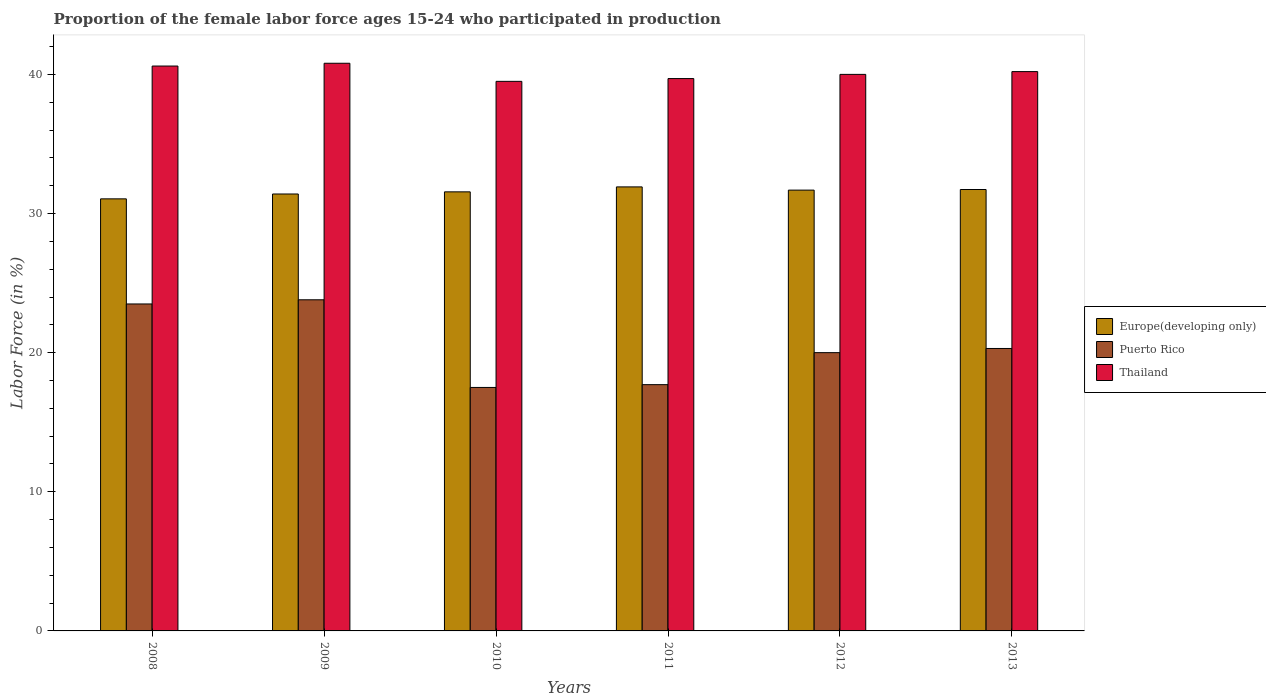Are the number of bars per tick equal to the number of legend labels?
Give a very brief answer. Yes. How many bars are there on the 4th tick from the right?
Ensure brevity in your answer.  3. What is the label of the 6th group of bars from the left?
Your response must be concise. 2013. In how many cases, is the number of bars for a given year not equal to the number of legend labels?
Give a very brief answer. 0. What is the proportion of the female labor force who participated in production in Puerto Rico in 2010?
Keep it short and to the point. 17.5. Across all years, what is the maximum proportion of the female labor force who participated in production in Puerto Rico?
Provide a short and direct response. 23.8. Across all years, what is the minimum proportion of the female labor force who participated in production in Puerto Rico?
Offer a very short reply. 17.5. In which year was the proportion of the female labor force who participated in production in Europe(developing only) maximum?
Make the answer very short. 2011. In which year was the proportion of the female labor force who participated in production in Thailand minimum?
Provide a succinct answer. 2010. What is the total proportion of the female labor force who participated in production in Europe(developing only) in the graph?
Ensure brevity in your answer.  189.34. What is the difference between the proportion of the female labor force who participated in production in Europe(developing only) in 2010 and that in 2012?
Provide a succinct answer. -0.12. What is the difference between the proportion of the female labor force who participated in production in Thailand in 2010 and the proportion of the female labor force who participated in production in Puerto Rico in 2013?
Make the answer very short. 19.2. What is the average proportion of the female labor force who participated in production in Europe(developing only) per year?
Offer a terse response. 31.56. In the year 2012, what is the difference between the proportion of the female labor force who participated in production in Europe(developing only) and proportion of the female labor force who participated in production in Thailand?
Offer a very short reply. -8.32. In how many years, is the proportion of the female labor force who participated in production in Puerto Rico greater than 14 %?
Provide a short and direct response. 6. What is the ratio of the proportion of the female labor force who participated in production in Puerto Rico in 2009 to that in 2012?
Your answer should be compact. 1.19. What is the difference between the highest and the second highest proportion of the female labor force who participated in production in Puerto Rico?
Give a very brief answer. 0.3. What is the difference between the highest and the lowest proportion of the female labor force who participated in production in Thailand?
Make the answer very short. 1.3. In how many years, is the proportion of the female labor force who participated in production in Thailand greater than the average proportion of the female labor force who participated in production in Thailand taken over all years?
Ensure brevity in your answer.  3. Is the sum of the proportion of the female labor force who participated in production in Europe(developing only) in 2011 and 2012 greater than the maximum proportion of the female labor force who participated in production in Thailand across all years?
Offer a terse response. Yes. What does the 2nd bar from the left in 2010 represents?
Ensure brevity in your answer.  Puerto Rico. What does the 3rd bar from the right in 2013 represents?
Your response must be concise. Europe(developing only). Are all the bars in the graph horizontal?
Your answer should be very brief. No. Are the values on the major ticks of Y-axis written in scientific E-notation?
Your response must be concise. No. Does the graph contain grids?
Your answer should be very brief. No. How are the legend labels stacked?
Make the answer very short. Vertical. What is the title of the graph?
Provide a short and direct response. Proportion of the female labor force ages 15-24 who participated in production. What is the Labor Force (in %) in Europe(developing only) in 2008?
Make the answer very short. 31.05. What is the Labor Force (in %) of Thailand in 2008?
Give a very brief answer. 40.6. What is the Labor Force (in %) of Europe(developing only) in 2009?
Provide a succinct answer. 31.4. What is the Labor Force (in %) of Puerto Rico in 2009?
Keep it short and to the point. 23.8. What is the Labor Force (in %) in Thailand in 2009?
Provide a short and direct response. 40.8. What is the Labor Force (in %) of Europe(developing only) in 2010?
Ensure brevity in your answer.  31.56. What is the Labor Force (in %) in Puerto Rico in 2010?
Give a very brief answer. 17.5. What is the Labor Force (in %) in Thailand in 2010?
Provide a succinct answer. 39.5. What is the Labor Force (in %) in Europe(developing only) in 2011?
Make the answer very short. 31.91. What is the Labor Force (in %) of Puerto Rico in 2011?
Offer a very short reply. 17.7. What is the Labor Force (in %) of Thailand in 2011?
Your answer should be very brief. 39.7. What is the Labor Force (in %) in Europe(developing only) in 2012?
Your answer should be compact. 31.68. What is the Labor Force (in %) in Puerto Rico in 2012?
Offer a terse response. 20. What is the Labor Force (in %) of Europe(developing only) in 2013?
Your answer should be very brief. 31.73. What is the Labor Force (in %) in Puerto Rico in 2013?
Offer a very short reply. 20.3. What is the Labor Force (in %) in Thailand in 2013?
Provide a short and direct response. 40.2. Across all years, what is the maximum Labor Force (in %) of Europe(developing only)?
Keep it short and to the point. 31.91. Across all years, what is the maximum Labor Force (in %) in Puerto Rico?
Provide a short and direct response. 23.8. Across all years, what is the maximum Labor Force (in %) in Thailand?
Your answer should be very brief. 40.8. Across all years, what is the minimum Labor Force (in %) in Europe(developing only)?
Make the answer very short. 31.05. Across all years, what is the minimum Labor Force (in %) in Puerto Rico?
Offer a very short reply. 17.5. Across all years, what is the minimum Labor Force (in %) in Thailand?
Your answer should be very brief. 39.5. What is the total Labor Force (in %) of Europe(developing only) in the graph?
Offer a terse response. 189.34. What is the total Labor Force (in %) of Puerto Rico in the graph?
Keep it short and to the point. 122.8. What is the total Labor Force (in %) of Thailand in the graph?
Your response must be concise. 240.8. What is the difference between the Labor Force (in %) of Europe(developing only) in 2008 and that in 2009?
Provide a short and direct response. -0.35. What is the difference between the Labor Force (in %) of Puerto Rico in 2008 and that in 2009?
Ensure brevity in your answer.  -0.3. What is the difference between the Labor Force (in %) in Europe(developing only) in 2008 and that in 2010?
Make the answer very short. -0.5. What is the difference between the Labor Force (in %) of Puerto Rico in 2008 and that in 2010?
Make the answer very short. 6. What is the difference between the Labor Force (in %) of Europe(developing only) in 2008 and that in 2011?
Keep it short and to the point. -0.86. What is the difference between the Labor Force (in %) in Europe(developing only) in 2008 and that in 2012?
Give a very brief answer. -0.63. What is the difference between the Labor Force (in %) of Thailand in 2008 and that in 2012?
Your answer should be compact. 0.6. What is the difference between the Labor Force (in %) in Europe(developing only) in 2008 and that in 2013?
Keep it short and to the point. -0.67. What is the difference between the Labor Force (in %) in Thailand in 2008 and that in 2013?
Your answer should be compact. 0.4. What is the difference between the Labor Force (in %) in Europe(developing only) in 2009 and that in 2010?
Provide a succinct answer. -0.15. What is the difference between the Labor Force (in %) of Thailand in 2009 and that in 2010?
Offer a very short reply. 1.3. What is the difference between the Labor Force (in %) of Europe(developing only) in 2009 and that in 2011?
Keep it short and to the point. -0.51. What is the difference between the Labor Force (in %) in Puerto Rico in 2009 and that in 2011?
Keep it short and to the point. 6.1. What is the difference between the Labor Force (in %) of Europe(developing only) in 2009 and that in 2012?
Offer a terse response. -0.28. What is the difference between the Labor Force (in %) of Europe(developing only) in 2009 and that in 2013?
Provide a short and direct response. -0.32. What is the difference between the Labor Force (in %) in Thailand in 2009 and that in 2013?
Provide a short and direct response. 0.6. What is the difference between the Labor Force (in %) of Europe(developing only) in 2010 and that in 2011?
Ensure brevity in your answer.  -0.36. What is the difference between the Labor Force (in %) in Puerto Rico in 2010 and that in 2011?
Give a very brief answer. -0.2. What is the difference between the Labor Force (in %) in Thailand in 2010 and that in 2011?
Your response must be concise. -0.2. What is the difference between the Labor Force (in %) of Europe(developing only) in 2010 and that in 2012?
Your answer should be very brief. -0.12. What is the difference between the Labor Force (in %) in Puerto Rico in 2010 and that in 2012?
Provide a short and direct response. -2.5. What is the difference between the Labor Force (in %) of Europe(developing only) in 2010 and that in 2013?
Give a very brief answer. -0.17. What is the difference between the Labor Force (in %) of Puerto Rico in 2010 and that in 2013?
Give a very brief answer. -2.8. What is the difference between the Labor Force (in %) in Thailand in 2010 and that in 2013?
Offer a very short reply. -0.7. What is the difference between the Labor Force (in %) in Europe(developing only) in 2011 and that in 2012?
Your response must be concise. 0.23. What is the difference between the Labor Force (in %) in Puerto Rico in 2011 and that in 2012?
Your answer should be very brief. -2.3. What is the difference between the Labor Force (in %) of Europe(developing only) in 2011 and that in 2013?
Your response must be concise. 0.19. What is the difference between the Labor Force (in %) of Puerto Rico in 2011 and that in 2013?
Make the answer very short. -2.6. What is the difference between the Labor Force (in %) in Thailand in 2011 and that in 2013?
Your answer should be very brief. -0.5. What is the difference between the Labor Force (in %) of Europe(developing only) in 2012 and that in 2013?
Your response must be concise. -0.04. What is the difference between the Labor Force (in %) in Thailand in 2012 and that in 2013?
Give a very brief answer. -0.2. What is the difference between the Labor Force (in %) in Europe(developing only) in 2008 and the Labor Force (in %) in Puerto Rico in 2009?
Keep it short and to the point. 7.25. What is the difference between the Labor Force (in %) of Europe(developing only) in 2008 and the Labor Force (in %) of Thailand in 2009?
Your answer should be very brief. -9.75. What is the difference between the Labor Force (in %) of Puerto Rico in 2008 and the Labor Force (in %) of Thailand in 2009?
Make the answer very short. -17.3. What is the difference between the Labor Force (in %) in Europe(developing only) in 2008 and the Labor Force (in %) in Puerto Rico in 2010?
Your answer should be very brief. 13.55. What is the difference between the Labor Force (in %) in Europe(developing only) in 2008 and the Labor Force (in %) in Thailand in 2010?
Your answer should be very brief. -8.45. What is the difference between the Labor Force (in %) in Puerto Rico in 2008 and the Labor Force (in %) in Thailand in 2010?
Your answer should be compact. -16. What is the difference between the Labor Force (in %) in Europe(developing only) in 2008 and the Labor Force (in %) in Puerto Rico in 2011?
Make the answer very short. 13.35. What is the difference between the Labor Force (in %) of Europe(developing only) in 2008 and the Labor Force (in %) of Thailand in 2011?
Provide a succinct answer. -8.65. What is the difference between the Labor Force (in %) of Puerto Rico in 2008 and the Labor Force (in %) of Thailand in 2011?
Your answer should be compact. -16.2. What is the difference between the Labor Force (in %) in Europe(developing only) in 2008 and the Labor Force (in %) in Puerto Rico in 2012?
Keep it short and to the point. 11.05. What is the difference between the Labor Force (in %) of Europe(developing only) in 2008 and the Labor Force (in %) of Thailand in 2012?
Offer a very short reply. -8.95. What is the difference between the Labor Force (in %) of Puerto Rico in 2008 and the Labor Force (in %) of Thailand in 2012?
Provide a succinct answer. -16.5. What is the difference between the Labor Force (in %) in Europe(developing only) in 2008 and the Labor Force (in %) in Puerto Rico in 2013?
Offer a very short reply. 10.75. What is the difference between the Labor Force (in %) of Europe(developing only) in 2008 and the Labor Force (in %) of Thailand in 2013?
Give a very brief answer. -9.15. What is the difference between the Labor Force (in %) in Puerto Rico in 2008 and the Labor Force (in %) in Thailand in 2013?
Provide a succinct answer. -16.7. What is the difference between the Labor Force (in %) of Europe(developing only) in 2009 and the Labor Force (in %) of Puerto Rico in 2010?
Provide a short and direct response. 13.9. What is the difference between the Labor Force (in %) of Europe(developing only) in 2009 and the Labor Force (in %) of Thailand in 2010?
Your answer should be compact. -8.1. What is the difference between the Labor Force (in %) of Puerto Rico in 2009 and the Labor Force (in %) of Thailand in 2010?
Ensure brevity in your answer.  -15.7. What is the difference between the Labor Force (in %) in Europe(developing only) in 2009 and the Labor Force (in %) in Puerto Rico in 2011?
Offer a terse response. 13.7. What is the difference between the Labor Force (in %) of Europe(developing only) in 2009 and the Labor Force (in %) of Thailand in 2011?
Offer a terse response. -8.3. What is the difference between the Labor Force (in %) in Puerto Rico in 2009 and the Labor Force (in %) in Thailand in 2011?
Ensure brevity in your answer.  -15.9. What is the difference between the Labor Force (in %) of Europe(developing only) in 2009 and the Labor Force (in %) of Puerto Rico in 2012?
Give a very brief answer. 11.4. What is the difference between the Labor Force (in %) of Europe(developing only) in 2009 and the Labor Force (in %) of Thailand in 2012?
Offer a very short reply. -8.6. What is the difference between the Labor Force (in %) of Puerto Rico in 2009 and the Labor Force (in %) of Thailand in 2012?
Provide a succinct answer. -16.2. What is the difference between the Labor Force (in %) of Europe(developing only) in 2009 and the Labor Force (in %) of Puerto Rico in 2013?
Keep it short and to the point. 11.1. What is the difference between the Labor Force (in %) in Europe(developing only) in 2009 and the Labor Force (in %) in Thailand in 2013?
Ensure brevity in your answer.  -8.8. What is the difference between the Labor Force (in %) of Puerto Rico in 2009 and the Labor Force (in %) of Thailand in 2013?
Your response must be concise. -16.4. What is the difference between the Labor Force (in %) of Europe(developing only) in 2010 and the Labor Force (in %) of Puerto Rico in 2011?
Your response must be concise. 13.86. What is the difference between the Labor Force (in %) of Europe(developing only) in 2010 and the Labor Force (in %) of Thailand in 2011?
Keep it short and to the point. -8.14. What is the difference between the Labor Force (in %) in Puerto Rico in 2010 and the Labor Force (in %) in Thailand in 2011?
Provide a short and direct response. -22.2. What is the difference between the Labor Force (in %) in Europe(developing only) in 2010 and the Labor Force (in %) in Puerto Rico in 2012?
Offer a terse response. 11.56. What is the difference between the Labor Force (in %) of Europe(developing only) in 2010 and the Labor Force (in %) of Thailand in 2012?
Offer a terse response. -8.44. What is the difference between the Labor Force (in %) in Puerto Rico in 2010 and the Labor Force (in %) in Thailand in 2012?
Your answer should be compact. -22.5. What is the difference between the Labor Force (in %) of Europe(developing only) in 2010 and the Labor Force (in %) of Puerto Rico in 2013?
Offer a very short reply. 11.26. What is the difference between the Labor Force (in %) of Europe(developing only) in 2010 and the Labor Force (in %) of Thailand in 2013?
Give a very brief answer. -8.64. What is the difference between the Labor Force (in %) of Puerto Rico in 2010 and the Labor Force (in %) of Thailand in 2013?
Ensure brevity in your answer.  -22.7. What is the difference between the Labor Force (in %) of Europe(developing only) in 2011 and the Labor Force (in %) of Puerto Rico in 2012?
Offer a very short reply. 11.91. What is the difference between the Labor Force (in %) in Europe(developing only) in 2011 and the Labor Force (in %) in Thailand in 2012?
Offer a terse response. -8.09. What is the difference between the Labor Force (in %) of Puerto Rico in 2011 and the Labor Force (in %) of Thailand in 2012?
Provide a succinct answer. -22.3. What is the difference between the Labor Force (in %) of Europe(developing only) in 2011 and the Labor Force (in %) of Puerto Rico in 2013?
Keep it short and to the point. 11.61. What is the difference between the Labor Force (in %) of Europe(developing only) in 2011 and the Labor Force (in %) of Thailand in 2013?
Ensure brevity in your answer.  -8.29. What is the difference between the Labor Force (in %) in Puerto Rico in 2011 and the Labor Force (in %) in Thailand in 2013?
Provide a succinct answer. -22.5. What is the difference between the Labor Force (in %) in Europe(developing only) in 2012 and the Labor Force (in %) in Puerto Rico in 2013?
Provide a short and direct response. 11.38. What is the difference between the Labor Force (in %) in Europe(developing only) in 2012 and the Labor Force (in %) in Thailand in 2013?
Make the answer very short. -8.52. What is the difference between the Labor Force (in %) in Puerto Rico in 2012 and the Labor Force (in %) in Thailand in 2013?
Your answer should be compact. -20.2. What is the average Labor Force (in %) of Europe(developing only) per year?
Ensure brevity in your answer.  31.56. What is the average Labor Force (in %) in Puerto Rico per year?
Keep it short and to the point. 20.47. What is the average Labor Force (in %) in Thailand per year?
Offer a terse response. 40.13. In the year 2008, what is the difference between the Labor Force (in %) in Europe(developing only) and Labor Force (in %) in Puerto Rico?
Give a very brief answer. 7.55. In the year 2008, what is the difference between the Labor Force (in %) in Europe(developing only) and Labor Force (in %) in Thailand?
Your response must be concise. -9.55. In the year 2008, what is the difference between the Labor Force (in %) of Puerto Rico and Labor Force (in %) of Thailand?
Ensure brevity in your answer.  -17.1. In the year 2009, what is the difference between the Labor Force (in %) in Europe(developing only) and Labor Force (in %) in Puerto Rico?
Your answer should be very brief. 7.6. In the year 2009, what is the difference between the Labor Force (in %) in Europe(developing only) and Labor Force (in %) in Thailand?
Ensure brevity in your answer.  -9.4. In the year 2009, what is the difference between the Labor Force (in %) in Puerto Rico and Labor Force (in %) in Thailand?
Keep it short and to the point. -17. In the year 2010, what is the difference between the Labor Force (in %) in Europe(developing only) and Labor Force (in %) in Puerto Rico?
Provide a short and direct response. 14.06. In the year 2010, what is the difference between the Labor Force (in %) in Europe(developing only) and Labor Force (in %) in Thailand?
Keep it short and to the point. -7.94. In the year 2010, what is the difference between the Labor Force (in %) in Puerto Rico and Labor Force (in %) in Thailand?
Keep it short and to the point. -22. In the year 2011, what is the difference between the Labor Force (in %) in Europe(developing only) and Labor Force (in %) in Puerto Rico?
Keep it short and to the point. 14.21. In the year 2011, what is the difference between the Labor Force (in %) in Europe(developing only) and Labor Force (in %) in Thailand?
Ensure brevity in your answer.  -7.79. In the year 2011, what is the difference between the Labor Force (in %) in Puerto Rico and Labor Force (in %) in Thailand?
Your answer should be compact. -22. In the year 2012, what is the difference between the Labor Force (in %) in Europe(developing only) and Labor Force (in %) in Puerto Rico?
Keep it short and to the point. 11.68. In the year 2012, what is the difference between the Labor Force (in %) of Europe(developing only) and Labor Force (in %) of Thailand?
Keep it short and to the point. -8.32. In the year 2013, what is the difference between the Labor Force (in %) of Europe(developing only) and Labor Force (in %) of Puerto Rico?
Offer a very short reply. 11.43. In the year 2013, what is the difference between the Labor Force (in %) in Europe(developing only) and Labor Force (in %) in Thailand?
Your answer should be compact. -8.47. In the year 2013, what is the difference between the Labor Force (in %) of Puerto Rico and Labor Force (in %) of Thailand?
Offer a very short reply. -19.9. What is the ratio of the Labor Force (in %) of Europe(developing only) in 2008 to that in 2009?
Provide a succinct answer. 0.99. What is the ratio of the Labor Force (in %) in Puerto Rico in 2008 to that in 2009?
Your answer should be very brief. 0.99. What is the ratio of the Labor Force (in %) in Thailand in 2008 to that in 2009?
Your response must be concise. 1. What is the ratio of the Labor Force (in %) of Europe(developing only) in 2008 to that in 2010?
Provide a succinct answer. 0.98. What is the ratio of the Labor Force (in %) in Puerto Rico in 2008 to that in 2010?
Offer a very short reply. 1.34. What is the ratio of the Labor Force (in %) of Thailand in 2008 to that in 2010?
Provide a short and direct response. 1.03. What is the ratio of the Labor Force (in %) in Europe(developing only) in 2008 to that in 2011?
Your answer should be compact. 0.97. What is the ratio of the Labor Force (in %) of Puerto Rico in 2008 to that in 2011?
Provide a succinct answer. 1.33. What is the ratio of the Labor Force (in %) in Thailand in 2008 to that in 2011?
Your answer should be very brief. 1.02. What is the ratio of the Labor Force (in %) of Europe(developing only) in 2008 to that in 2012?
Your answer should be very brief. 0.98. What is the ratio of the Labor Force (in %) in Puerto Rico in 2008 to that in 2012?
Your response must be concise. 1.18. What is the ratio of the Labor Force (in %) of Europe(developing only) in 2008 to that in 2013?
Provide a succinct answer. 0.98. What is the ratio of the Labor Force (in %) of Puerto Rico in 2008 to that in 2013?
Make the answer very short. 1.16. What is the ratio of the Labor Force (in %) of Thailand in 2008 to that in 2013?
Provide a short and direct response. 1.01. What is the ratio of the Labor Force (in %) of Puerto Rico in 2009 to that in 2010?
Your answer should be very brief. 1.36. What is the ratio of the Labor Force (in %) in Thailand in 2009 to that in 2010?
Provide a short and direct response. 1.03. What is the ratio of the Labor Force (in %) in Puerto Rico in 2009 to that in 2011?
Your answer should be very brief. 1.34. What is the ratio of the Labor Force (in %) in Thailand in 2009 to that in 2011?
Ensure brevity in your answer.  1.03. What is the ratio of the Labor Force (in %) of Europe(developing only) in 2009 to that in 2012?
Give a very brief answer. 0.99. What is the ratio of the Labor Force (in %) of Puerto Rico in 2009 to that in 2012?
Your answer should be very brief. 1.19. What is the ratio of the Labor Force (in %) in Thailand in 2009 to that in 2012?
Provide a succinct answer. 1.02. What is the ratio of the Labor Force (in %) of Puerto Rico in 2009 to that in 2013?
Ensure brevity in your answer.  1.17. What is the ratio of the Labor Force (in %) of Thailand in 2009 to that in 2013?
Your answer should be very brief. 1.01. What is the ratio of the Labor Force (in %) of Europe(developing only) in 2010 to that in 2011?
Keep it short and to the point. 0.99. What is the ratio of the Labor Force (in %) in Puerto Rico in 2010 to that in 2011?
Provide a short and direct response. 0.99. What is the ratio of the Labor Force (in %) of Europe(developing only) in 2010 to that in 2012?
Provide a succinct answer. 1. What is the ratio of the Labor Force (in %) in Puerto Rico in 2010 to that in 2012?
Keep it short and to the point. 0.88. What is the ratio of the Labor Force (in %) of Thailand in 2010 to that in 2012?
Provide a succinct answer. 0.99. What is the ratio of the Labor Force (in %) in Europe(developing only) in 2010 to that in 2013?
Provide a short and direct response. 0.99. What is the ratio of the Labor Force (in %) of Puerto Rico in 2010 to that in 2013?
Make the answer very short. 0.86. What is the ratio of the Labor Force (in %) of Thailand in 2010 to that in 2013?
Your answer should be very brief. 0.98. What is the ratio of the Labor Force (in %) in Europe(developing only) in 2011 to that in 2012?
Provide a succinct answer. 1.01. What is the ratio of the Labor Force (in %) in Puerto Rico in 2011 to that in 2012?
Your answer should be very brief. 0.89. What is the ratio of the Labor Force (in %) of Europe(developing only) in 2011 to that in 2013?
Provide a succinct answer. 1.01. What is the ratio of the Labor Force (in %) in Puerto Rico in 2011 to that in 2013?
Offer a terse response. 0.87. What is the ratio of the Labor Force (in %) in Thailand in 2011 to that in 2013?
Your answer should be very brief. 0.99. What is the ratio of the Labor Force (in %) of Puerto Rico in 2012 to that in 2013?
Your answer should be compact. 0.99. What is the difference between the highest and the second highest Labor Force (in %) in Europe(developing only)?
Keep it short and to the point. 0.19. What is the difference between the highest and the second highest Labor Force (in %) in Puerto Rico?
Provide a succinct answer. 0.3. What is the difference between the highest and the second highest Labor Force (in %) of Thailand?
Provide a succinct answer. 0.2. What is the difference between the highest and the lowest Labor Force (in %) of Europe(developing only)?
Make the answer very short. 0.86. What is the difference between the highest and the lowest Labor Force (in %) of Puerto Rico?
Ensure brevity in your answer.  6.3. What is the difference between the highest and the lowest Labor Force (in %) in Thailand?
Your answer should be compact. 1.3. 